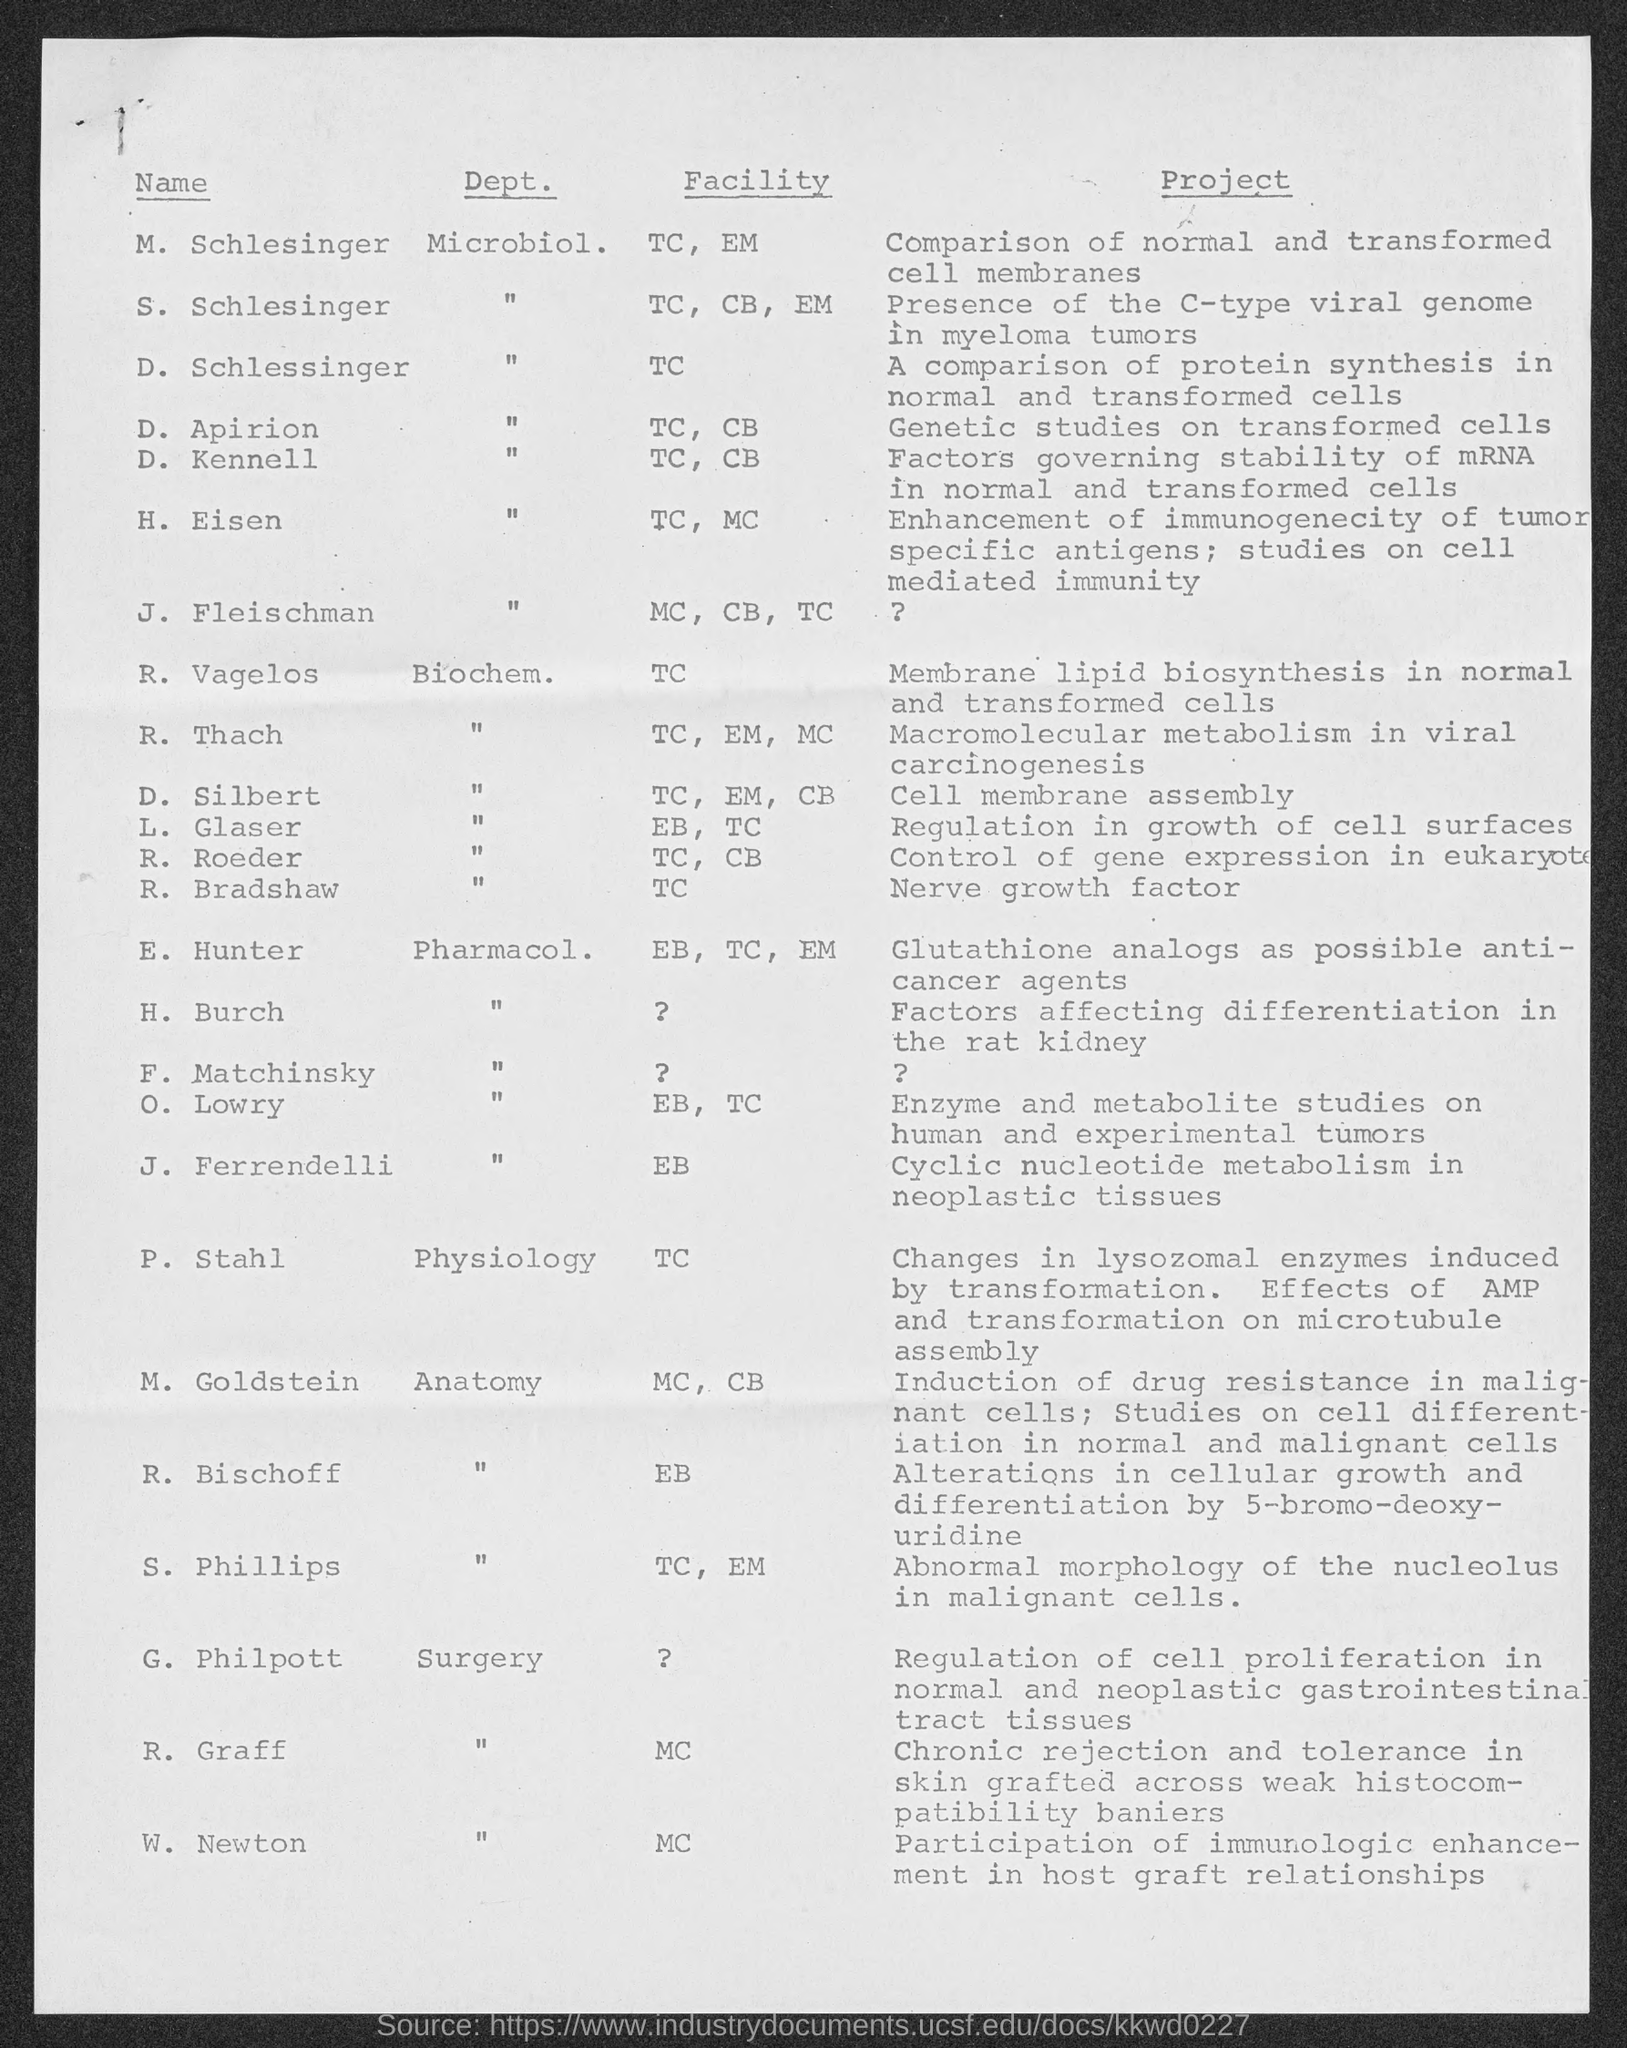Outline some significant characteristics in this image. Dr. M. Schlesinger is a member of the Department of Microbiology. The project of J. Ferrendelli is to investigate cyclic nucleotide metabolism in neoplastic tissues. H. Eisen is part of both the Technology Center and the Media Center. R. Thach is the head of Macromolecular metabolism in viral carcinogenesis. The project of D. Apirion involves conducting genetic studies on transformed cells. 